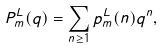<formula> <loc_0><loc_0><loc_500><loc_500>P _ { m } ^ { L } ( q ) = \sum _ { n \geq 1 } p _ { m } ^ { L } ( n ) q ^ { n } ,</formula> 